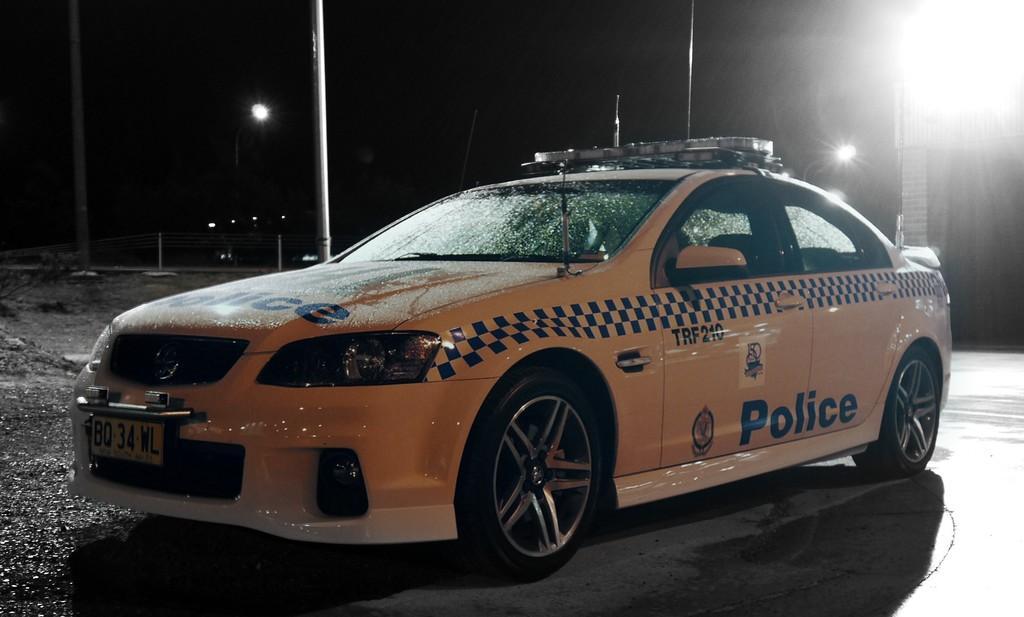Could you give a brief overview of what you see in this image? In this picture we can see a car on the road, lights, poles, fence and in the background it is dark. 